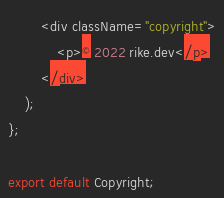Convert code to text. <code><loc_0><loc_0><loc_500><loc_500><_JavaScript_>        <div className="copyright">
            <p>© 2022 rike.dev</p>
        </div>
    );
};

export default Copyright;
</code> 